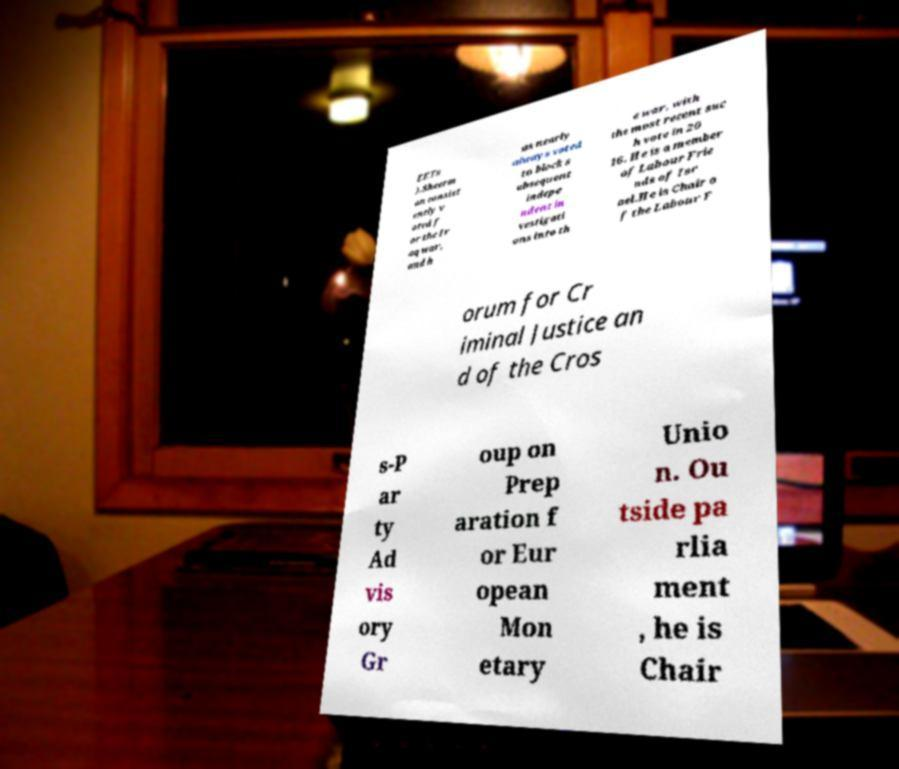For documentation purposes, I need the text within this image transcribed. Could you provide that? EETs ).Sheerm an consist ently v oted f or the Ir aq war, and h as nearly always voted to block s ubsequent indepe ndent in vestigati ons into th e war, with the most recent suc h vote in 20 16. He is a member of Labour Frie nds of Isr ael.He is Chair o f the Labour F orum for Cr iminal Justice an d of the Cros s-P ar ty Ad vis ory Gr oup on Prep aration f or Eur opean Mon etary Unio n. Ou tside pa rlia ment , he is Chair 